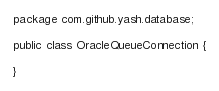Convert code to text. <code><loc_0><loc_0><loc_500><loc_500><_Java_>package com.github.yash.database;

public class OracleQueueConnection {

}
</code> 